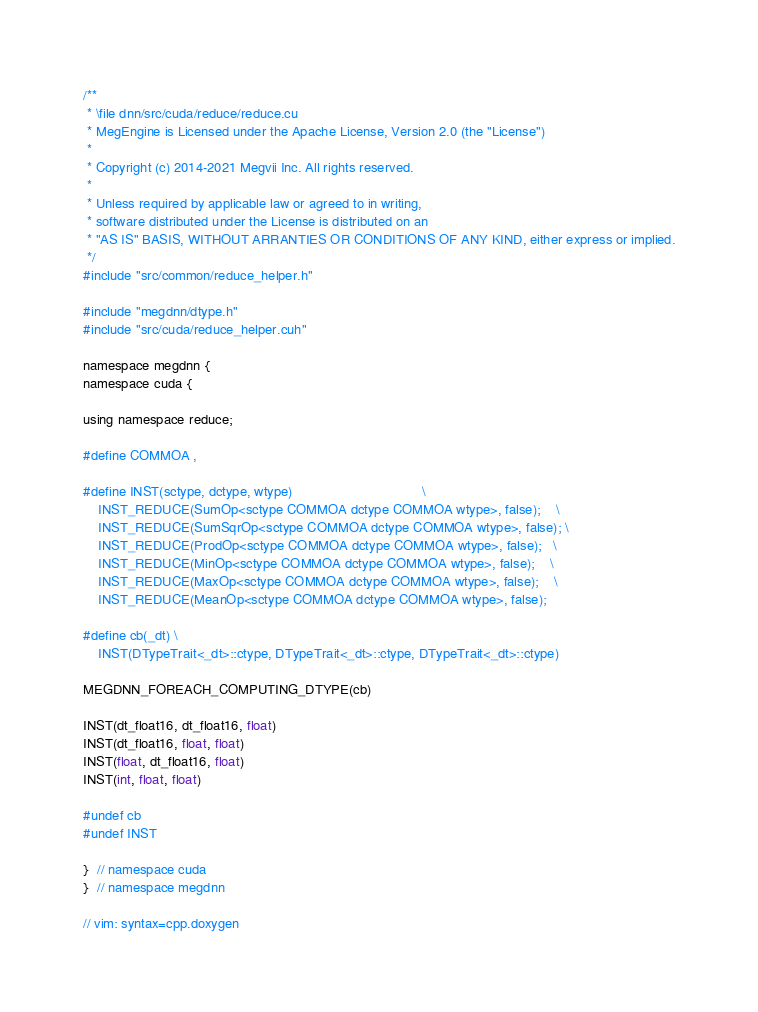Convert code to text. <code><loc_0><loc_0><loc_500><loc_500><_Cuda_>/**
 * \file dnn/src/cuda/reduce/reduce.cu
 * MegEngine is Licensed under the Apache License, Version 2.0 (the "License")
 *
 * Copyright (c) 2014-2021 Megvii Inc. All rights reserved.
 *
 * Unless required by applicable law or agreed to in writing,
 * software distributed under the License is distributed on an
 * "AS IS" BASIS, WITHOUT ARRANTIES OR CONDITIONS OF ANY KIND, either express or implied.
 */
#include "src/common/reduce_helper.h"

#include "megdnn/dtype.h"
#include "src/cuda/reduce_helper.cuh"

namespace megdnn {
namespace cuda {

using namespace reduce;

#define COMMOA ,

#define INST(sctype, dctype, wtype)                                  \
    INST_REDUCE(SumOp<sctype COMMOA dctype COMMOA wtype>, false);    \
    INST_REDUCE(SumSqrOp<sctype COMMOA dctype COMMOA wtype>, false); \
    INST_REDUCE(ProdOp<sctype COMMOA dctype COMMOA wtype>, false);   \
    INST_REDUCE(MinOp<sctype COMMOA dctype COMMOA wtype>, false);    \
    INST_REDUCE(MaxOp<sctype COMMOA dctype COMMOA wtype>, false);    \
    INST_REDUCE(MeanOp<sctype COMMOA dctype COMMOA wtype>, false);

#define cb(_dt) \
    INST(DTypeTrait<_dt>::ctype, DTypeTrait<_dt>::ctype, DTypeTrait<_dt>::ctype)

MEGDNN_FOREACH_COMPUTING_DTYPE(cb)

INST(dt_float16, dt_float16, float)
INST(dt_float16, float, float)
INST(float, dt_float16, float)
INST(int, float, float)

#undef cb
#undef INST

}  // namespace cuda
}  // namespace megdnn

// vim: syntax=cpp.doxygen
</code> 